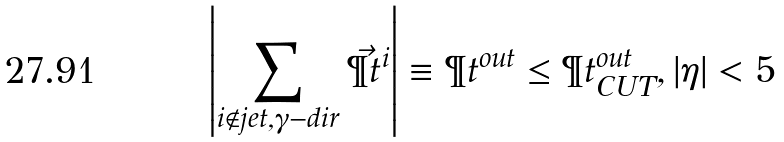<formula> <loc_0><loc_0><loc_500><loc_500>\left | \sum _ { i \not \in j e t , \gamma - d i r } \vec { \P t } ^ { i } \right | \equiv \P t ^ { o u t } \leq \P t ^ { o u t } _ { C U T } , | \eta | < 5</formula> 